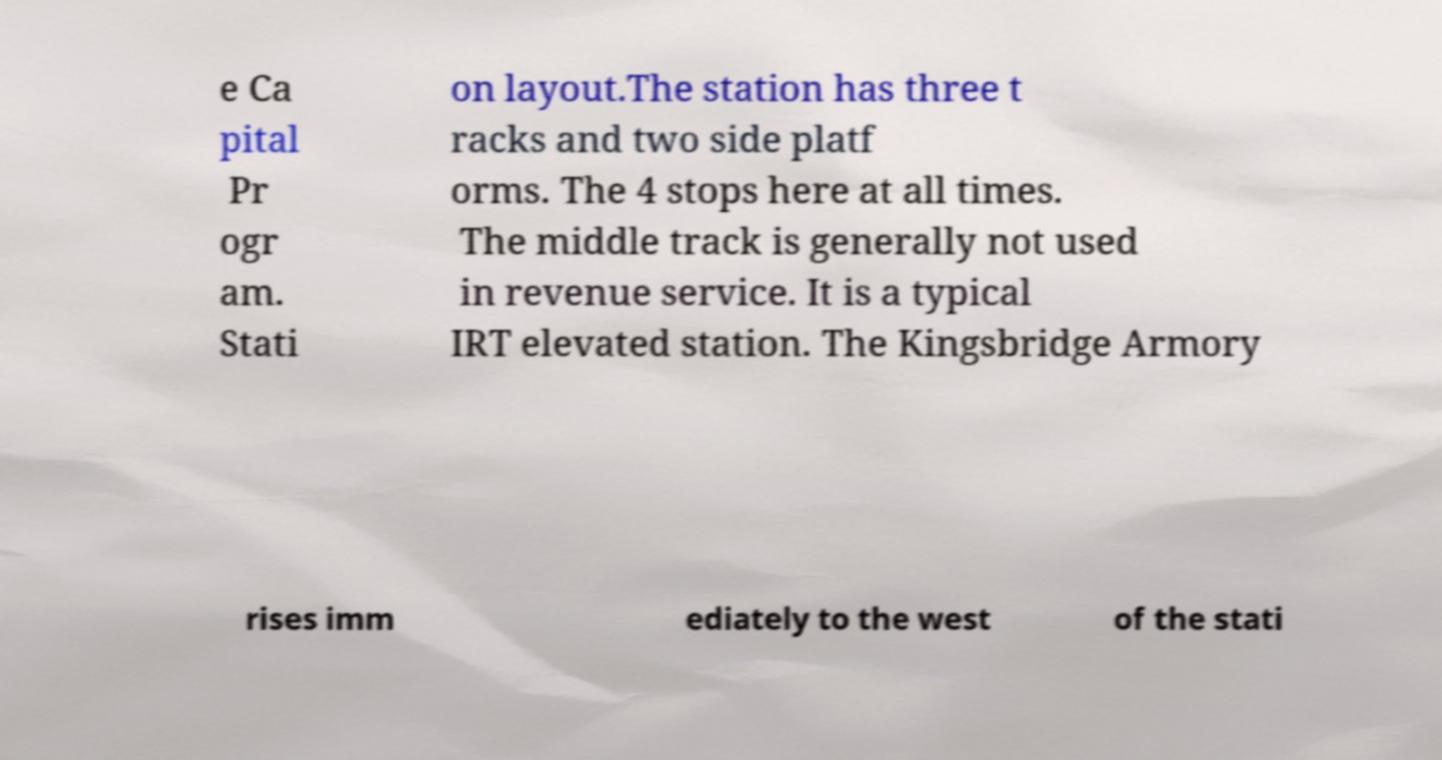I need the written content from this picture converted into text. Can you do that? e Ca pital Pr ogr am. Stati on layout.The station has three t racks and two side platf orms. The 4 stops here at all times. The middle track is generally not used in revenue service. It is a typical IRT elevated station. The Kingsbridge Armory rises imm ediately to the west of the stati 